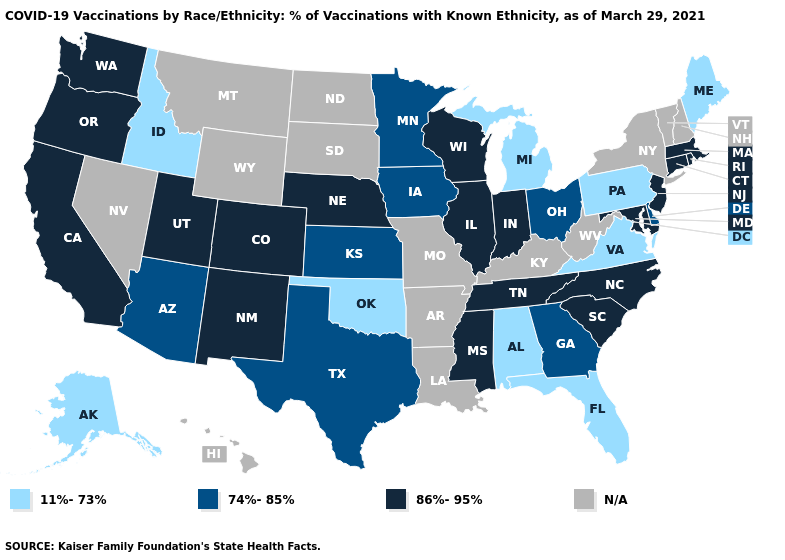Name the states that have a value in the range 11%-73%?
Be succinct. Alabama, Alaska, Florida, Idaho, Maine, Michigan, Oklahoma, Pennsylvania, Virginia. What is the lowest value in states that border Maryland?
Answer briefly. 11%-73%. What is the highest value in the USA?
Give a very brief answer. 86%-95%. Name the states that have a value in the range 86%-95%?
Concise answer only. California, Colorado, Connecticut, Illinois, Indiana, Maryland, Massachusetts, Mississippi, Nebraska, New Jersey, New Mexico, North Carolina, Oregon, Rhode Island, South Carolina, Tennessee, Utah, Washington, Wisconsin. Among the states that border Indiana , does Illinois have the highest value?
Keep it brief. Yes. What is the value of Delaware?
Keep it brief. 74%-85%. Does Tennessee have the highest value in the South?
Be succinct. Yes. What is the value of California?
Keep it brief. 86%-95%. Among the states that border Oklahoma , does Colorado have the lowest value?
Answer briefly. No. Name the states that have a value in the range N/A?
Answer briefly. Arkansas, Hawaii, Kentucky, Louisiana, Missouri, Montana, Nevada, New Hampshire, New York, North Dakota, South Dakota, Vermont, West Virginia, Wyoming. Name the states that have a value in the range 74%-85%?
Short answer required. Arizona, Delaware, Georgia, Iowa, Kansas, Minnesota, Ohio, Texas. What is the lowest value in states that border Wyoming?
Be succinct. 11%-73%. Which states have the lowest value in the USA?
Keep it brief. Alabama, Alaska, Florida, Idaho, Maine, Michigan, Oklahoma, Pennsylvania, Virginia. 